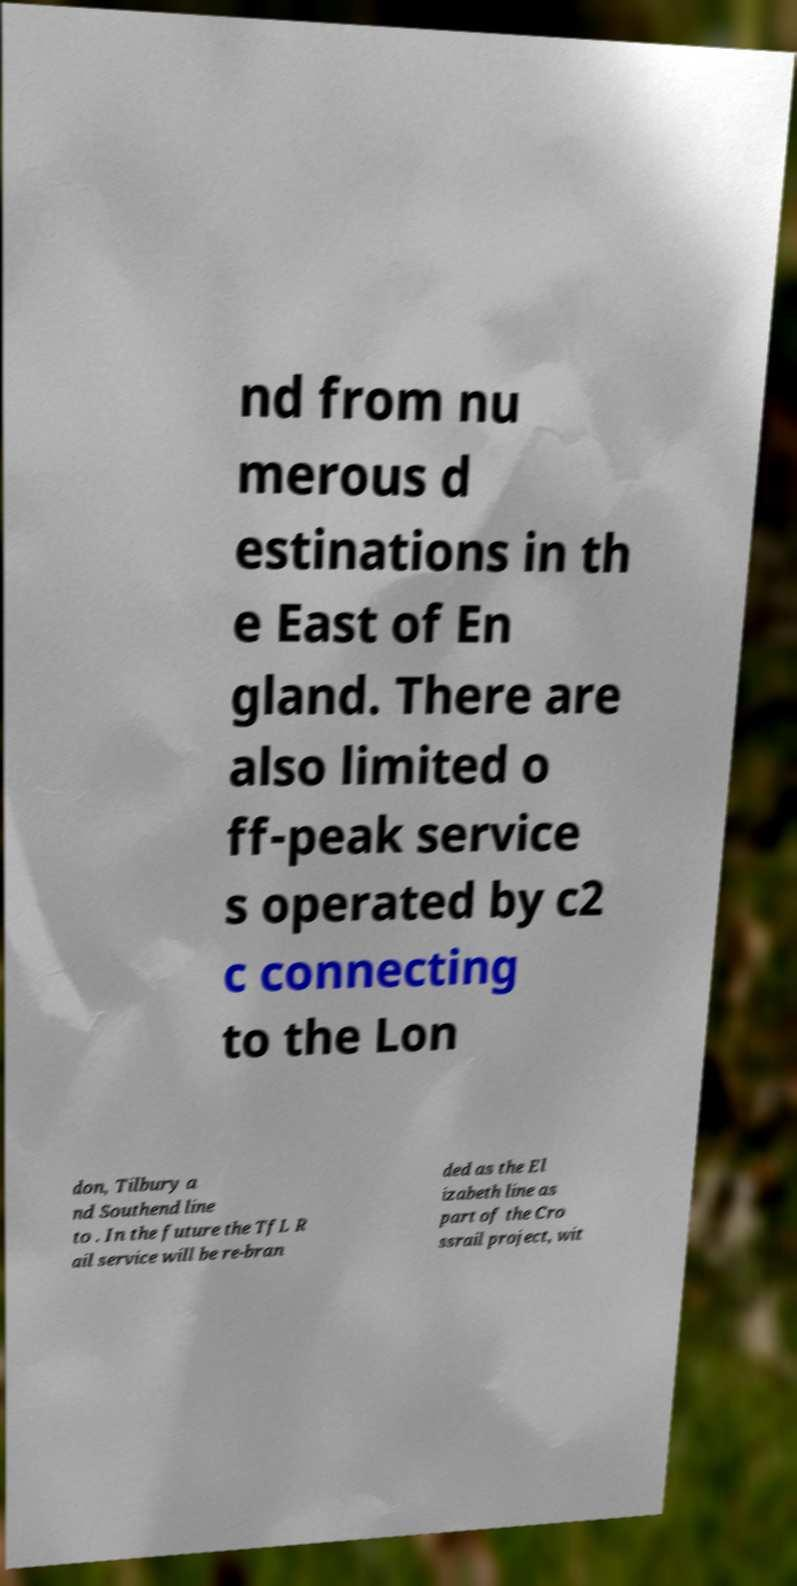Could you extract and type out the text from this image? nd from nu merous d estinations in th e East of En gland. There are also limited o ff-peak service s operated by c2 c connecting to the Lon don, Tilbury a nd Southend line to . In the future the TfL R ail service will be re-bran ded as the El izabeth line as part of the Cro ssrail project, wit 